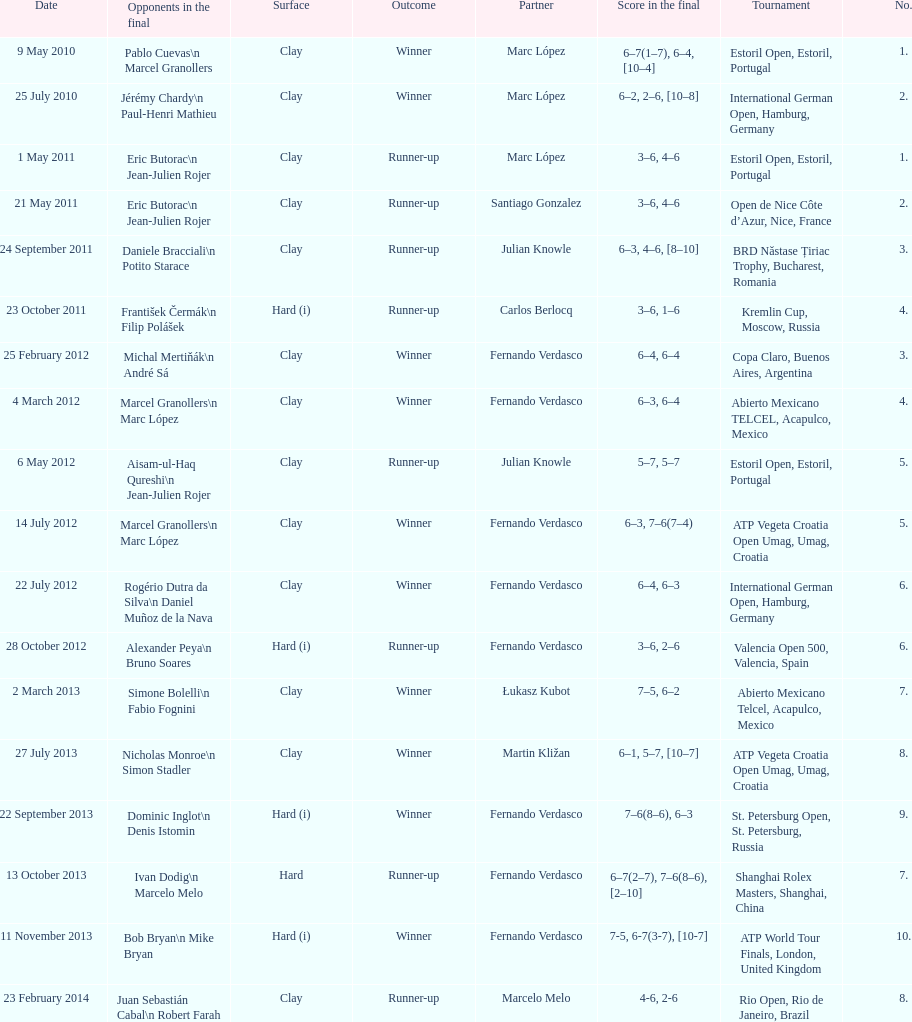How many partners from spain are listed? 2. 